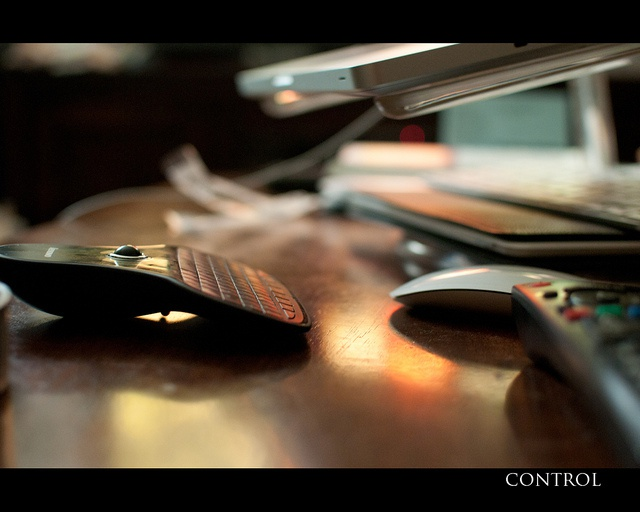Describe the objects in this image and their specific colors. I can see remote in black, gray, and maroon tones, remote in black, gray, and maroon tones, keyboard in black, beige, tan, gray, and darkgray tones, mouse in black, darkgray, lightgray, and gray tones, and keyboard in black, gray, and tan tones in this image. 